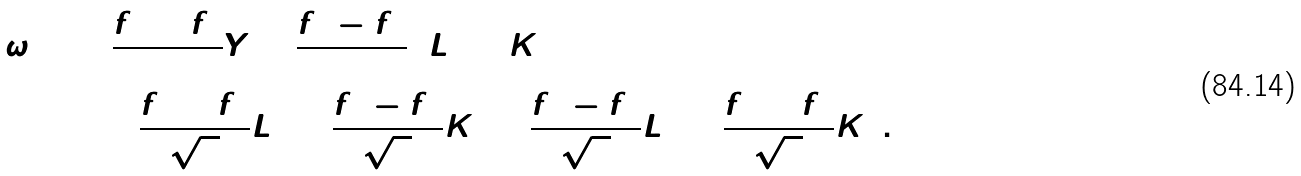Convert formula to latex. <formula><loc_0><loc_0><loc_500><loc_500>\omega _ { ( 1 ) } & = \frac { f ^ { 3 } + f ^ { 4 } } { 2 } Y + \frac { f ^ { 3 } - f ^ { 4 } } { 2 } \left ( L _ { 1 } + K _ { 1 } \right ) \\ & \quad + \frac { f ^ { 5 } + f ^ { 8 } } { \sqrt { 2 } } L _ { 2 } + \frac { f ^ { 5 } - f ^ { 8 } } { \sqrt { 2 } } K _ { 2 } + \frac { f ^ { 7 } - f ^ { 6 } } { \sqrt { 2 } } L _ { 3 } + \frac { f ^ { 6 } + f ^ { 7 } } { \sqrt { 2 } } K _ { 3 } \, .</formula> 